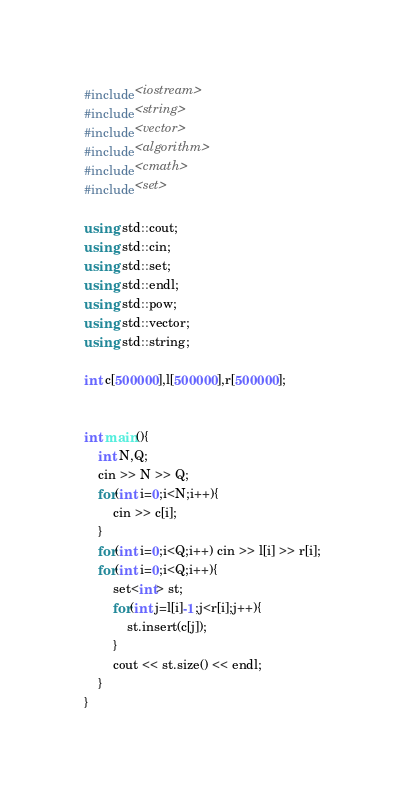<code> <loc_0><loc_0><loc_500><loc_500><_C++_>#include<iostream>
#include<string>
#include<vector>
#include<algorithm>
#include<cmath>
#include<set>

using std::cout;
using std::cin;
using std::set;
using std::endl;
using std::pow;
using std::vector;
using std::string;

int c[500000],l[500000],r[500000];


int main(){
    int N,Q;
    cin >> N >> Q;
    for(int i=0;i<N;i++){
        cin >> c[i];
    }
    for(int i=0;i<Q;i++) cin >> l[i] >> r[i];
    for(int i=0;i<Q;i++){
        set<int> st;
        for(int j=l[i]-1;j<r[i];j++){
            st.insert(c[j]);
        }
        cout << st.size() << endl;
    }
}</code> 